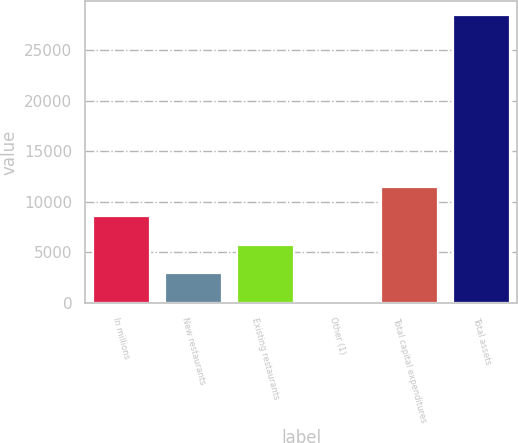<chart> <loc_0><loc_0><loc_500><loc_500><bar_chart><fcel>In millions<fcel>New restaurants<fcel>Existing restaurants<fcel>Other (1)<fcel>Total capital expenditures<fcel>Total assets<nl><fcel>8599.5<fcel>2924.5<fcel>5762<fcel>87<fcel>11437<fcel>28462<nl></chart> 